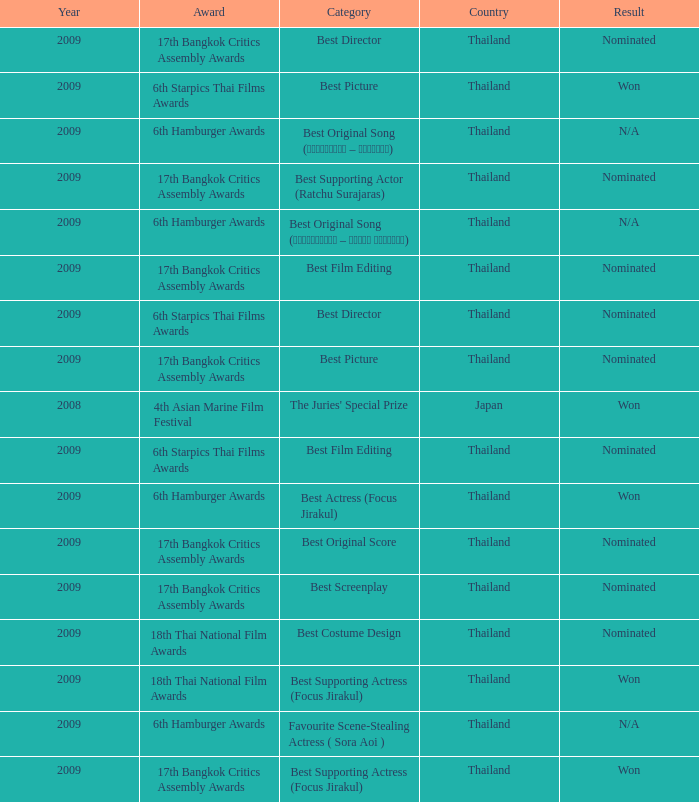Which Country has a Result of nominated, an Award of 17th bangkok critics assembly awards, and a Category of best screenplay? Thailand. 